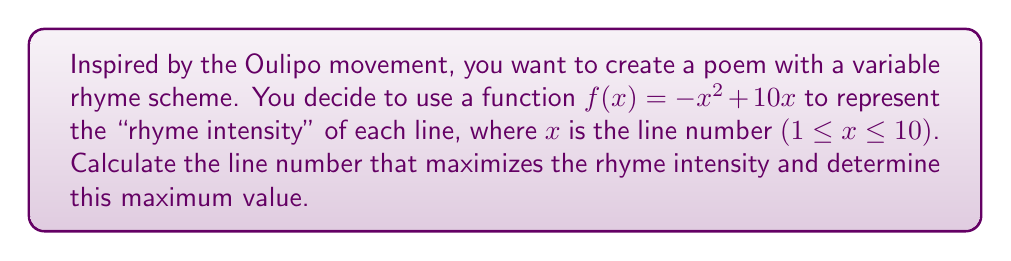Teach me how to tackle this problem. To find the maximum value of the rhyme intensity function, we need to use optimization techniques involving derivatives. Let's approach this step-by-step:

1) The given function is $f(x) = -x^2 + 10x$

2) To find the maximum, we need to find where the derivative equals zero:
   $$f'(x) = -2x + 10$$

3) Set $f'(x) = 0$ and solve for $x$:
   $$-2x + 10 = 0$$
   $$-2x = -10$$
   $$x = 5$$

4) To confirm this is a maximum (not a minimum), check the second derivative:
   $$f''(x) = -2$$
   Since $f''(x)$ is negative, $x = 5$ indeed gives a maximum.

5) Calculate the maximum value by plugging $x = 5$ into the original function:
   $$f(5) = -(5)^2 + 10(5) = -25 + 50 = 25$$

6) Note that since we're dealing with line numbers, we should check if $x = 5$ is within our domain (1 ≤ x ≤ 10). It is, so this is our answer.

Therefore, the rhyme intensity is maximized at line 5, with a value of 25.
Answer: Line 5; Maximum value: 25 